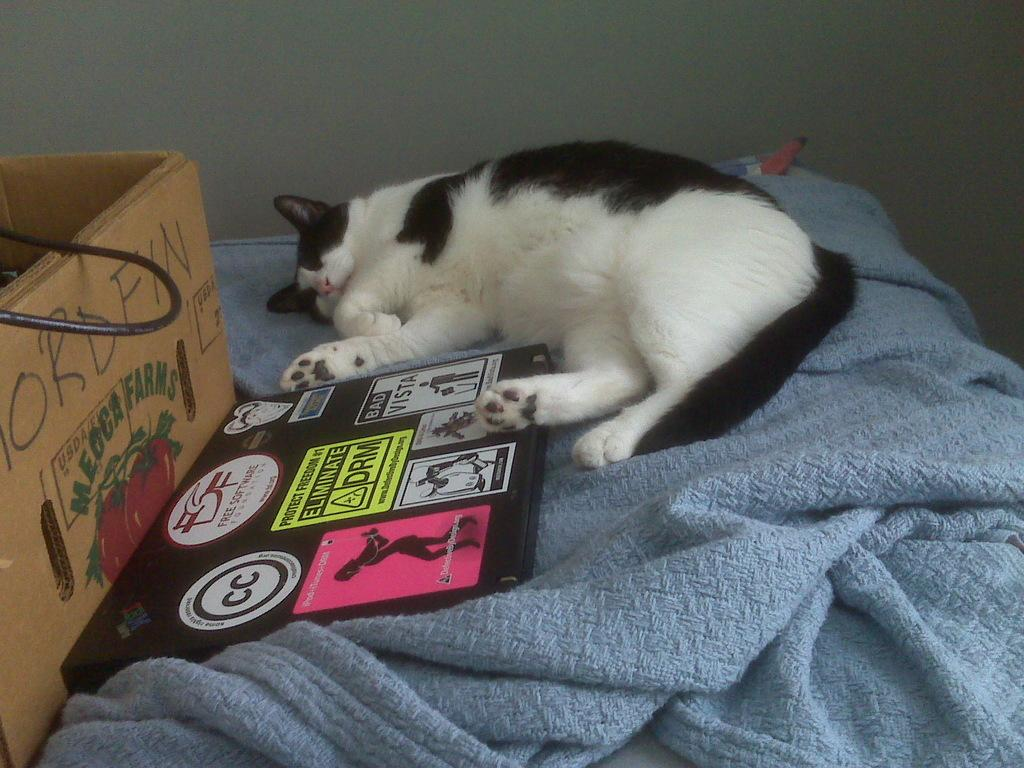<image>
Create a compact narrative representing the image presented. black and white cat sleeping next to a box and poster that has eliminate drm on it 